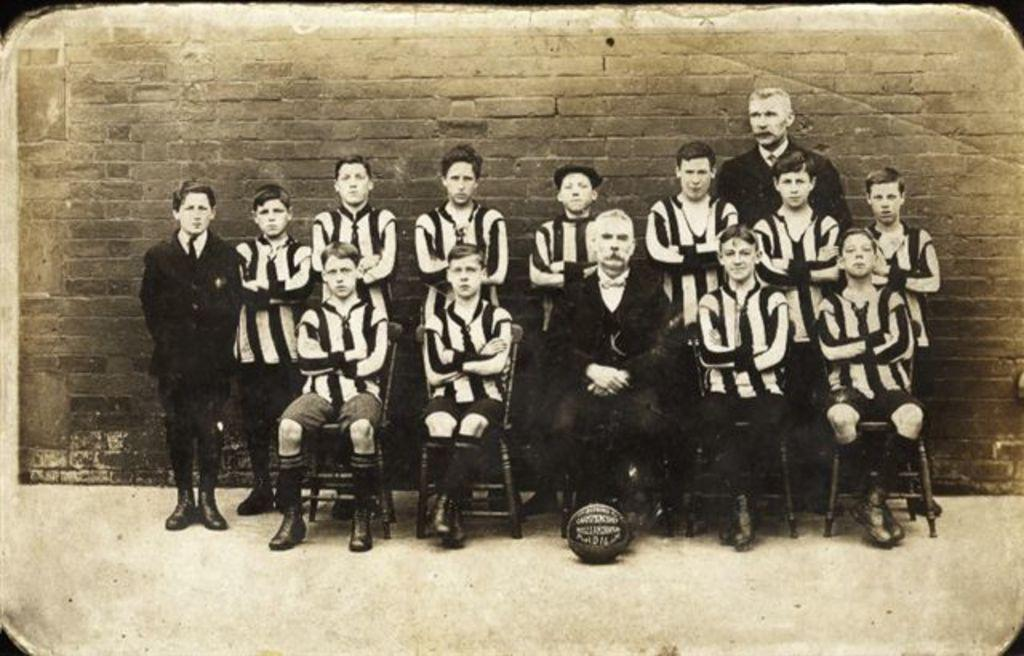What is the color scheme of the image? The image is black and white. What are the people in the image doing? There are people sitting on chairs in the image, and there are people standing behind the seated people. What can be seen in the background of the image? There is a wall in the background of the image. Can you tell me how many nuts are on the floor in the image? There are no nuts present in the image; it features people sitting and standing in a black and white setting. Is the grandmother visible in the image? There is no mention of a grandmother in the provided facts, and no such person is visible in the image. 